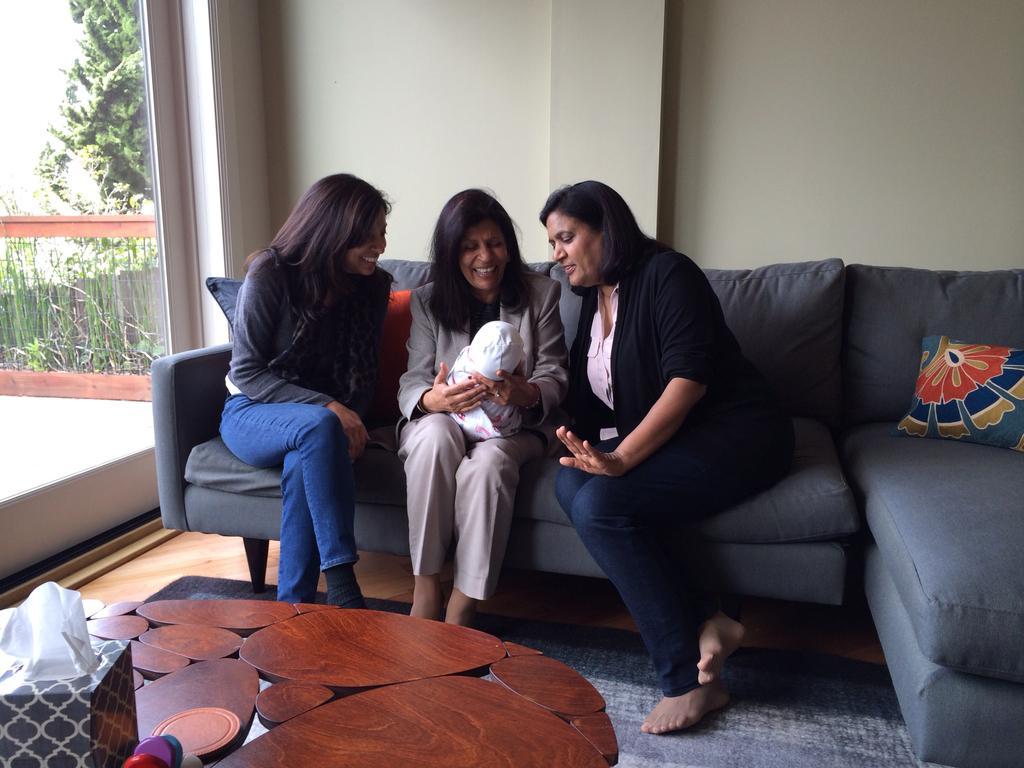Could you give a brief overview of what you see in this image? There are women sitting on a sofa. The women sitting in the middle is holding a baby. There is a table in the in front of the image and at the left side of the image there is a tree and at the right side of the image there is a pillow on sofa. 